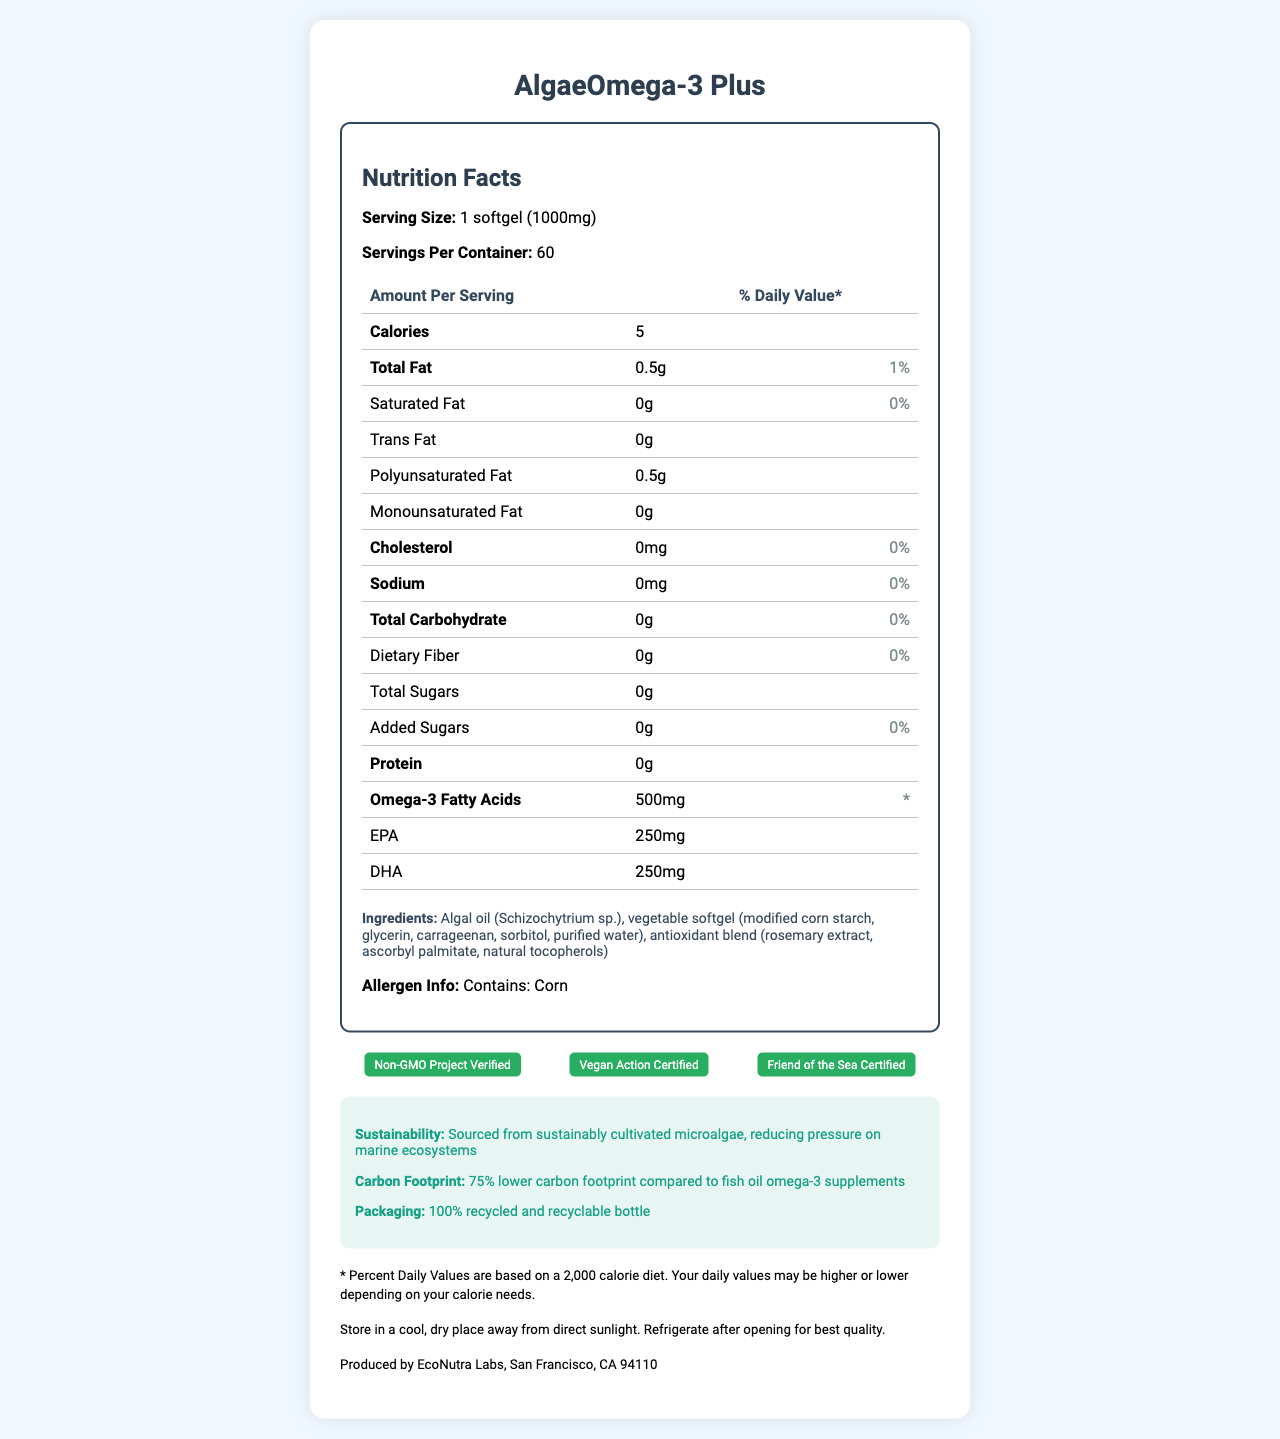how many calories are in one serving? The label shows that each serving size contains 5 calories.
Answer: 5 what is the serving size of AlgaeOmega-3 Plus? The label specifies that the serving size is 1 softgel (1000mg).
Answer: 1 softgel (1000mg) how much total fat does one serving contain? The label indicates that one serving contains 0.5 grams of total fat.
Answer: 0.5g what percentage of the daily value of saturated fat is in each serving? The label lists the daily value percentage of saturated fat as 0%.
Answer: 0% does the product contain any cholesterol? The label shows that the amount of cholesterol per serving is 0mg, which is 0% of the daily value.
Answer: No how much EPA is present per serving? The detailed breakdown on the label shows that each serving contains 250mg of EPA.
Answer: 250mg what type of oil is used in this supplement? The ingredients section states that the supplement contains algal oil (Schizochytrium sp.).
Answer: Algal oil (Schizochytrium sp.) how is the product sourced in terms of sustainability? The sustainability info section mentions that the product is sourced from sustainably cultivated microalgae.
Answer: Sourced from sustainably cultivated microalgae which of the following certifications does the product have?  
I. Non-GMO Project Verified  
II. Vegan Action Certified  
III. USDA Organic  
A. I and II  
B. II and III  
C. I, II, and III  
D. I only The label lists that the product is Non-GMO Project Verified and Vegan Action Certified, but it does not mention USDA Organic.
Answer: A. I and II which ingredient is not part of the vegetable softgel? A. Modified corn starch B. Glycerin C. Sorbitol D. Rosemary extract The vegetable softgel consists of modified corn starch, glycerin, carrageenan, sorbitol, and purified water, while rosemary extract is part of the antioxidant blend.
Answer: D. Rosemary extract does this supplement contain any added sugars? The label shows that the amount of added sugars per serving is 0g, which is 0% of the daily value.
Answer: No is the bottle packaging recyclable? The sustainability info states that the packaging is a 100% recycled and recyclable bottle.
Answer: Yes summarize the main features of AlgaeOmega-3 Plus. The label presents detailed nutritional information, certifications, and sustainability details for AlgaeOmega-3 Plus, highlighting its environmental benefits and health features.
Answer: AlgaeOmega-3 Plus is a sustainable, algae-based omega-3 supplement that provides 500mg of omega-3 fatty acids per serving, including 250mg of EPA and 250mg of DHA. It is vegan, non-GMO, and friend of the sea certified. Each serving has 5 calories, 0.5g of total fat, and no sugars, cholesterol, sodium, or protein. The product is packaged in a 100% recycled and recyclable bottle, with a significantly lower carbon footprint compared to fish oil supplements. where can you buy this supplement? The label does not provide any information regarding where to purchase the supplement.
Answer: Not enough information 